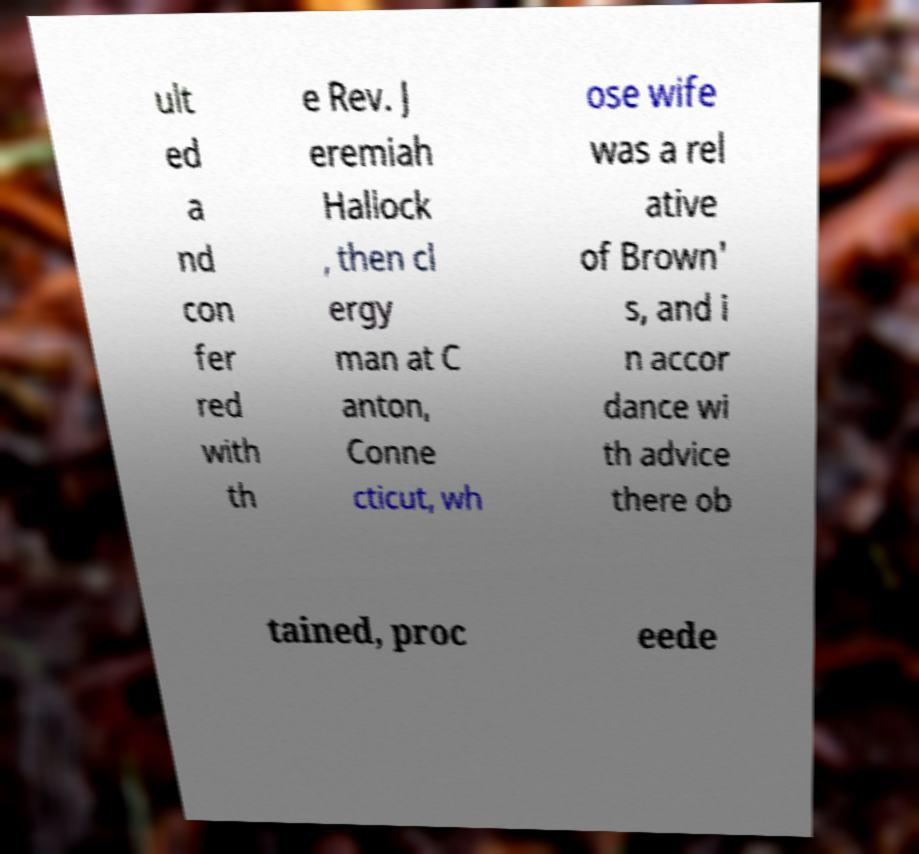I need the written content from this picture converted into text. Can you do that? ult ed a nd con fer red with th e Rev. J eremiah Hallock , then cl ergy man at C anton, Conne cticut, wh ose wife was a rel ative of Brown' s, and i n accor dance wi th advice there ob tained, proc eede 